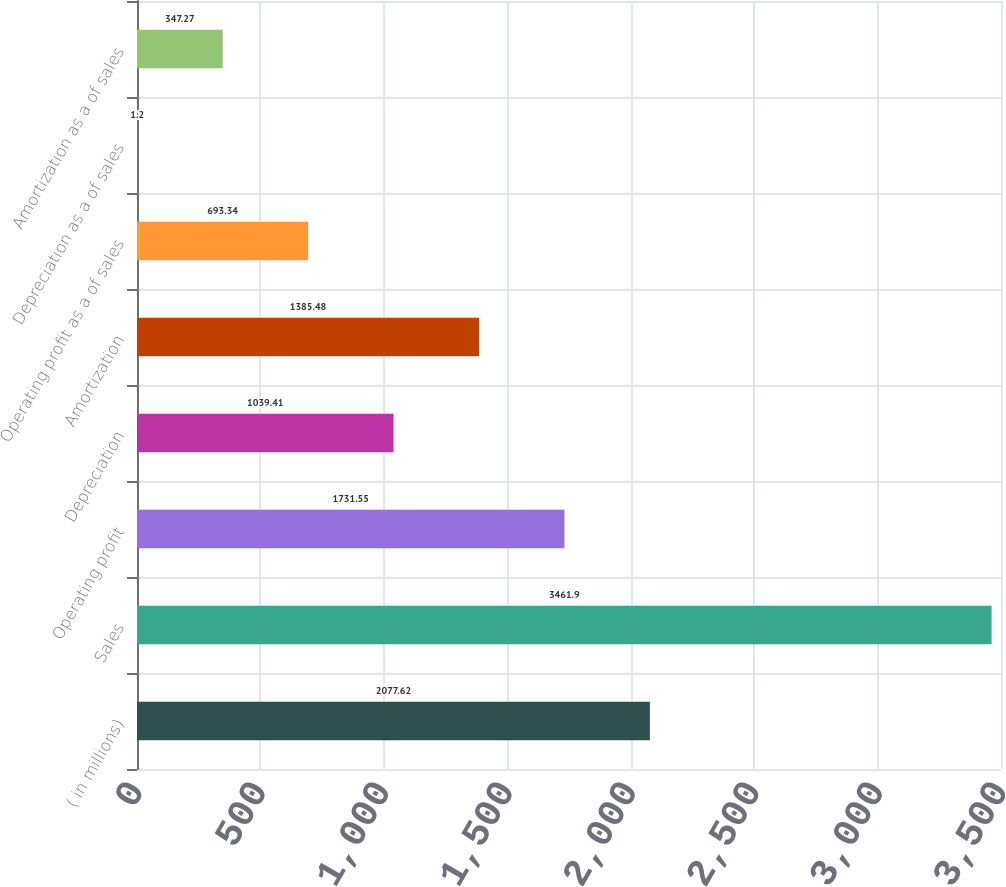Convert chart to OTSL. <chart><loc_0><loc_0><loc_500><loc_500><bar_chart><fcel>( in millions)<fcel>Sales<fcel>Operating profit<fcel>Depreciation<fcel>Amortization<fcel>Operating profit as a of sales<fcel>Depreciation as a of sales<fcel>Amortization as a of sales<nl><fcel>2077.62<fcel>3461.9<fcel>1731.55<fcel>1039.41<fcel>1385.48<fcel>693.34<fcel>1.2<fcel>347.27<nl></chart> 